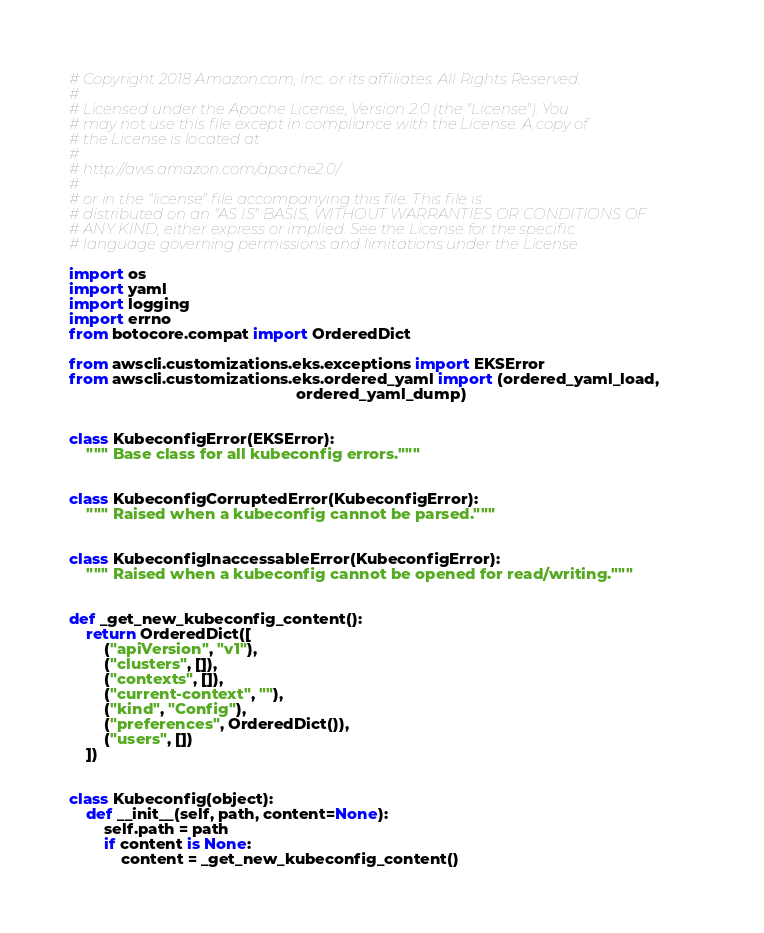Convert code to text. <code><loc_0><loc_0><loc_500><loc_500><_Python_># Copyright 2018 Amazon.com, Inc. or its affiliates. All Rights Reserved.
#
# Licensed under the Apache License, Version 2.0 (the "License"). You
# may not use this file except in compliance with the License. A copy of
# the License is located at
#
# http://aws.amazon.com/apache2.0/
#
# or in the "license" file accompanying this file. This file is
# distributed on an "AS IS" BASIS, WITHOUT WARRANTIES OR CONDITIONS OF
# ANY KIND, either express or implied. See the License for the specific
# language governing permissions and limitations under the License.

import os
import yaml
import logging
import errno
from botocore.compat import OrderedDict

from awscli.customizations.eks.exceptions import EKSError
from awscli.customizations.eks.ordered_yaml import (ordered_yaml_load,
                                                    ordered_yaml_dump)


class KubeconfigError(EKSError):
    """ Base class for all kubeconfig errors."""


class KubeconfigCorruptedError(KubeconfigError):
    """ Raised when a kubeconfig cannot be parsed."""


class KubeconfigInaccessableError(KubeconfigError):
    """ Raised when a kubeconfig cannot be opened for read/writing."""


def _get_new_kubeconfig_content():
    return OrderedDict([
        ("apiVersion", "v1"),
        ("clusters", []),
        ("contexts", []),
        ("current-context", ""),
        ("kind", "Config"),
        ("preferences", OrderedDict()),
        ("users", [])
    ])


class Kubeconfig(object):
    def __init__(self, path, content=None):
        self.path = path
        if content is None:
            content = _get_new_kubeconfig_content()</code> 